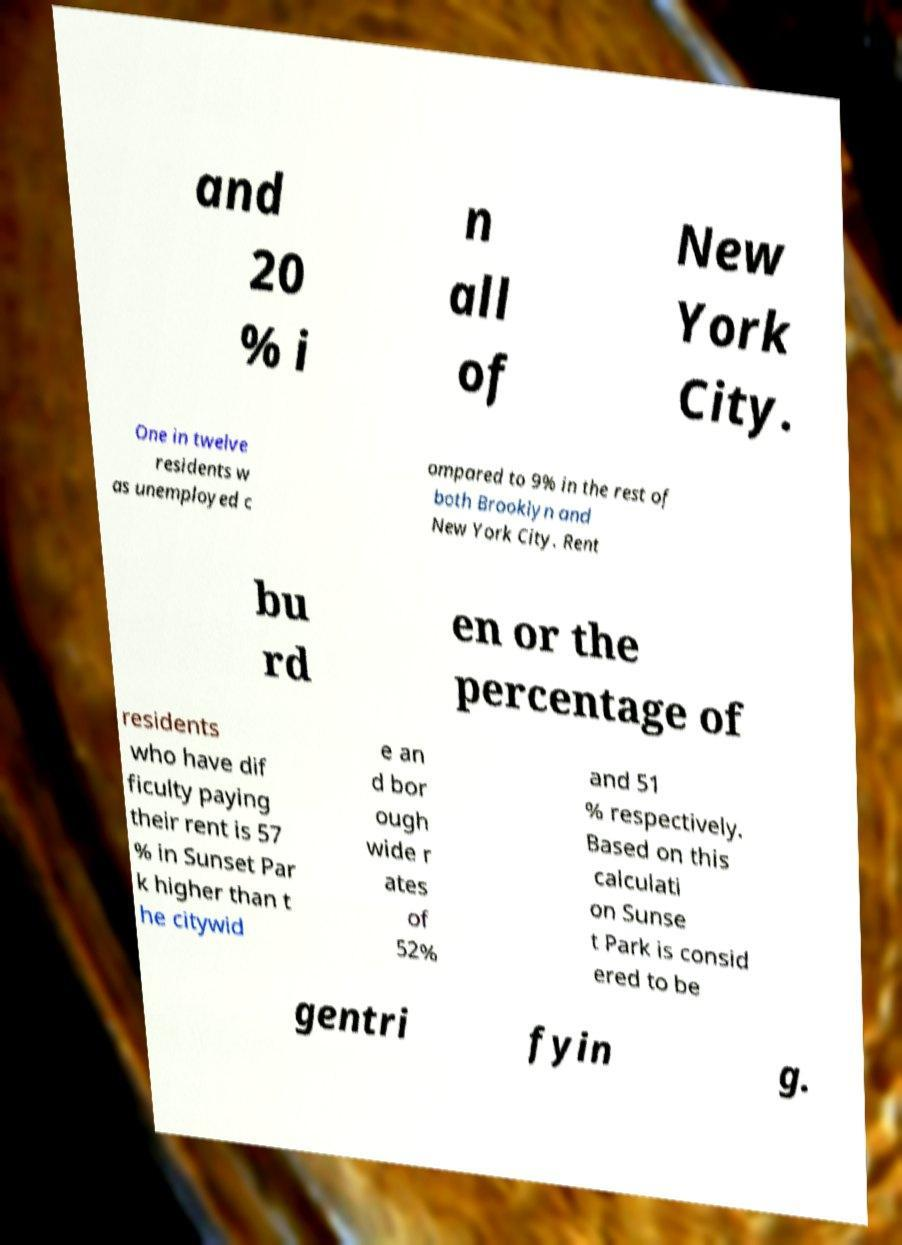There's text embedded in this image that I need extracted. Can you transcribe it verbatim? and 20 % i n all of New York City. One in twelve residents w as unemployed c ompared to 9% in the rest of both Brooklyn and New York City. Rent bu rd en or the percentage of residents who have dif ficulty paying their rent is 57 % in Sunset Par k higher than t he citywid e an d bor ough wide r ates of 52% and 51 % respectively. Based on this calculati on Sunse t Park is consid ered to be gentri fyin g. 